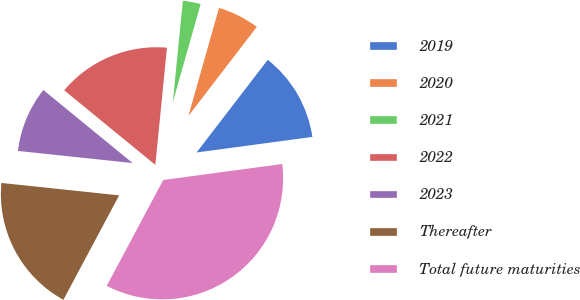<chart> <loc_0><loc_0><loc_500><loc_500><pie_chart><fcel>2019<fcel>2020<fcel>2021<fcel>2022<fcel>2023<fcel>Thereafter<fcel>Total future maturities<nl><fcel>12.45%<fcel>6.03%<fcel>2.82%<fcel>15.66%<fcel>9.24%<fcel>18.87%<fcel>34.93%<nl></chart> 